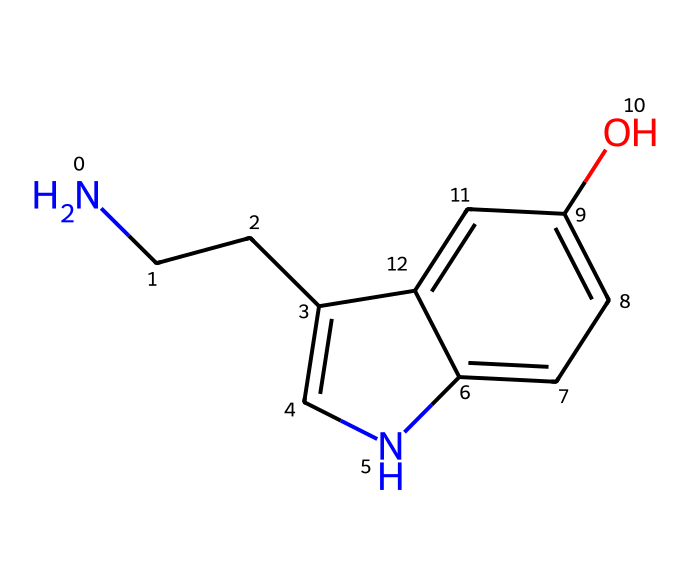How many nitrogen atoms are in this chemical? By inspecting the SMILES representation, we can see the presence of two nitrogen atoms indicated by "N". Counting each "N" leads us to conclude that there are indeed two nitrogen atoms present in the structure.
Answer: two What is the functional group present in the structure? The strategy here involves looking for specific arrangements of atoms that define functional groups. In this case, the presence of the "O" in the structure indicates a hydroxyl (-OH) group is present, which confirms the presence of a phenolic alcohol functional group.
Answer: hydroxyl How many rings are present in the structure? A thorough examination of the rings in the structure is essential. The SMILES representation indicates binding between carbon atoms that forms cyclic portions. In this instance, we identify that there are two interconnected rings.
Answer: two What type of molecule is serotonin classified as? To determine the classification, one must evaluate both the presence of amine and hydroxyl groups, which is characteristic of neurotransmitters. Given that serotonin plays a significant role in neurotransmission, it fits into the category of biological molecules known as neurotransmitters.
Answer: neurotransmitter What does the “c[nH]” indicate in the chemical structure? Here, one should focus on understanding the nomenclature in the SMILES representation. "c" indicates a carbon in an aromatic system, while "[nH]" represents a nitrogen in an aromatic setting with a hydrogen attached—typically indicating it is protonated. This highlights that nitrogen is part of the aromatic ring.
Answer: an aromatic nitrogen Which part of the structure is primarily responsible for serotonin's role in mood regulation? Understanding the role of serotonin in the body requires recognizing that the interactions between amine and hydroxyl groups facilitate neurotransmission. The position of these functional groups impacts how serotonin interacts with receptors in the brain, which regulates mood.
Answer: amine and hydroxyl groups 